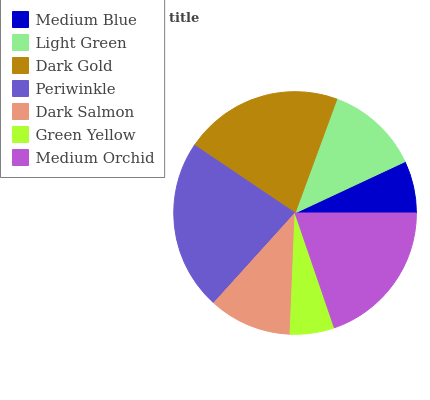Is Green Yellow the minimum?
Answer yes or no. Yes. Is Periwinkle the maximum?
Answer yes or no. Yes. Is Light Green the minimum?
Answer yes or no. No. Is Light Green the maximum?
Answer yes or no. No. Is Light Green greater than Medium Blue?
Answer yes or no. Yes. Is Medium Blue less than Light Green?
Answer yes or no. Yes. Is Medium Blue greater than Light Green?
Answer yes or no. No. Is Light Green less than Medium Blue?
Answer yes or no. No. Is Light Green the high median?
Answer yes or no. Yes. Is Light Green the low median?
Answer yes or no. Yes. Is Dark Salmon the high median?
Answer yes or no. No. Is Green Yellow the low median?
Answer yes or no. No. 